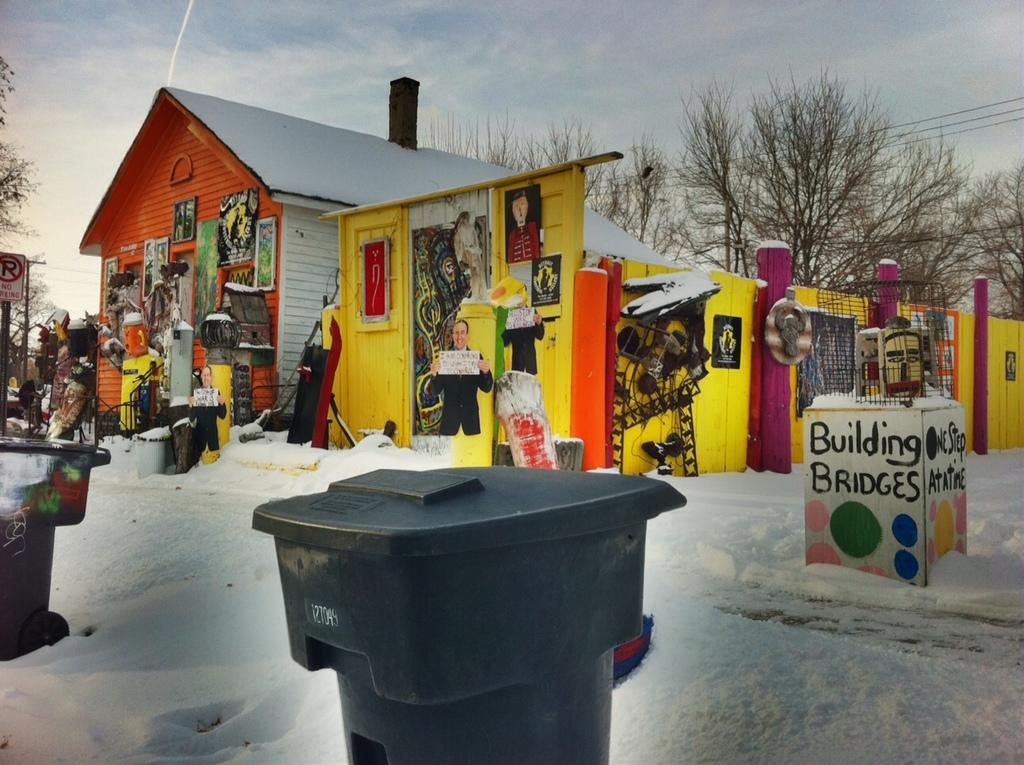What is being built?
Provide a succinct answer. Bridges. What is wrote on the right of the building bridges sign?
Ensure brevity in your answer.  One step at a time. 